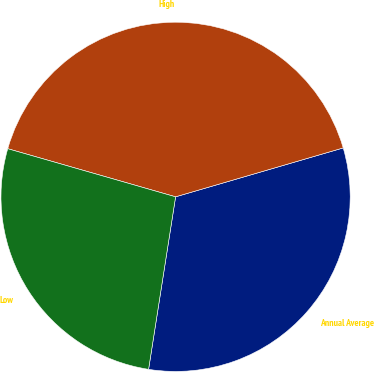Convert chart. <chart><loc_0><loc_0><loc_500><loc_500><pie_chart><fcel>Annual Average<fcel>High<fcel>Low<nl><fcel>31.99%<fcel>41.04%<fcel>26.97%<nl></chart> 